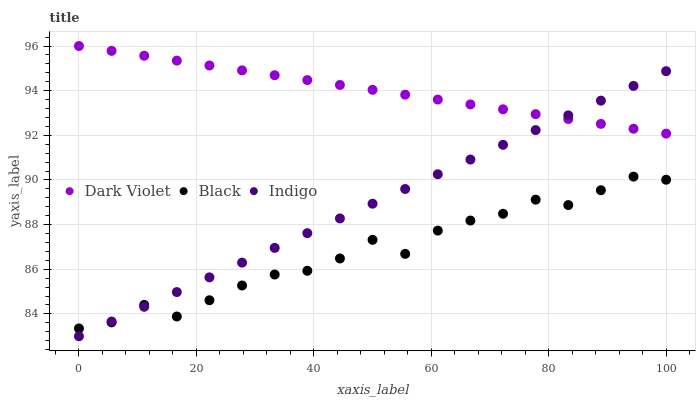Does Black have the minimum area under the curve?
Answer yes or no. Yes. Does Dark Violet have the maximum area under the curve?
Answer yes or no. Yes. Does Dark Violet have the minimum area under the curve?
Answer yes or no. No. Does Black have the maximum area under the curve?
Answer yes or no. No. Is Dark Violet the smoothest?
Answer yes or no. Yes. Is Black the roughest?
Answer yes or no. Yes. Is Black the smoothest?
Answer yes or no. No. Is Dark Violet the roughest?
Answer yes or no. No. Does Indigo have the lowest value?
Answer yes or no. Yes. Does Black have the lowest value?
Answer yes or no. No. Does Dark Violet have the highest value?
Answer yes or no. Yes. Does Black have the highest value?
Answer yes or no. No. Is Black less than Dark Violet?
Answer yes or no. Yes. Is Dark Violet greater than Black?
Answer yes or no. Yes. Does Indigo intersect Black?
Answer yes or no. Yes. Is Indigo less than Black?
Answer yes or no. No. Is Indigo greater than Black?
Answer yes or no. No. Does Black intersect Dark Violet?
Answer yes or no. No. 